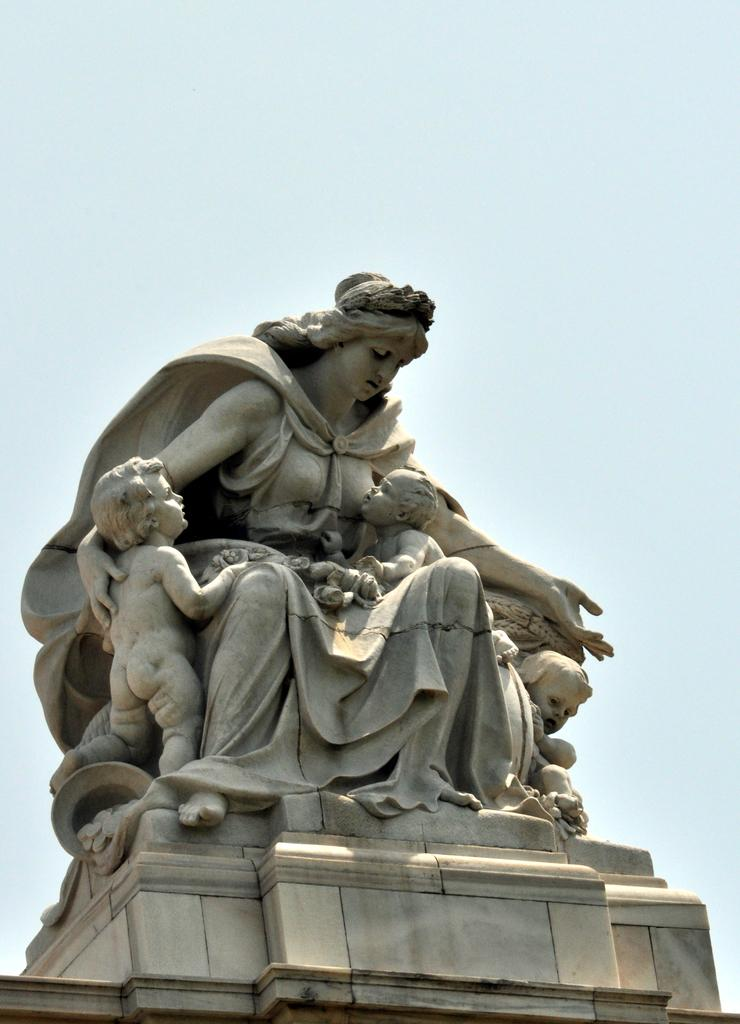What is the main subject of the image? There is a statue in the image. How is the statue positioned in the image? The statue is on a stand. What can be seen in the background of the image? The sky is visible in the background of the image. Where is the nearest shop to the statue in the image? There is no information about a shop or its location in the image. 